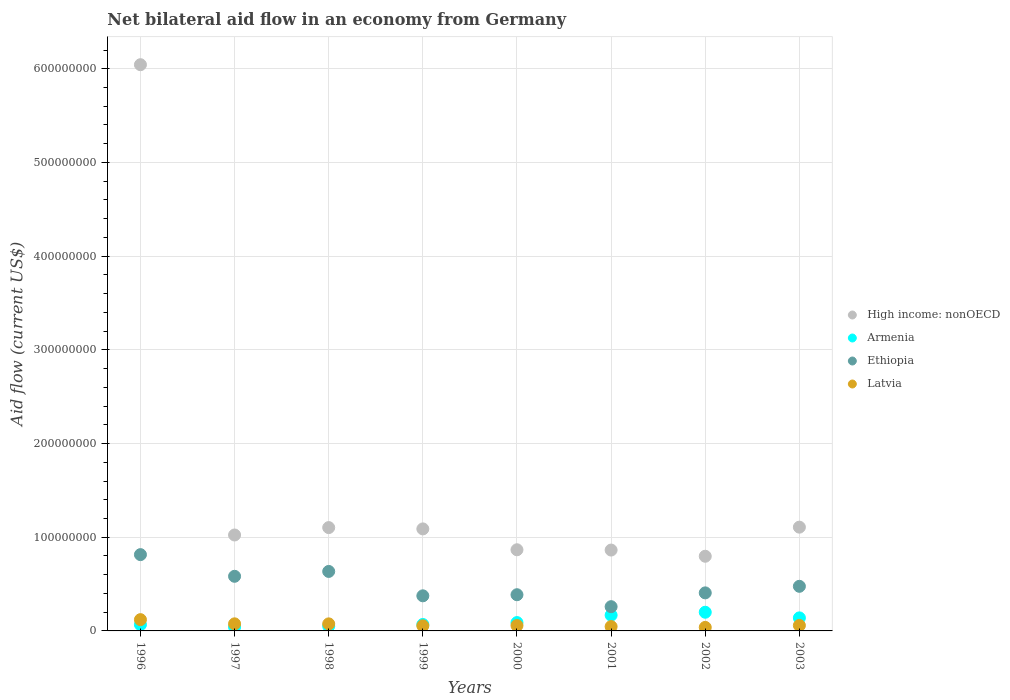How many different coloured dotlines are there?
Keep it short and to the point. 4. What is the net bilateral aid flow in Armenia in 2003?
Give a very brief answer. 1.39e+07. Across all years, what is the maximum net bilateral aid flow in Ethiopia?
Give a very brief answer. 8.14e+07. Across all years, what is the minimum net bilateral aid flow in High income: nonOECD?
Offer a very short reply. 7.97e+07. What is the total net bilateral aid flow in High income: nonOECD in the graph?
Provide a short and direct response. 1.29e+09. What is the difference between the net bilateral aid flow in Latvia in 1996 and that in 2001?
Give a very brief answer. 7.40e+06. What is the difference between the net bilateral aid flow in Armenia in 1998 and the net bilateral aid flow in Latvia in 1997?
Make the answer very short. -2.49e+06. What is the average net bilateral aid flow in Latvia per year?
Offer a very short reply. 6.57e+06. In the year 2000, what is the difference between the net bilateral aid flow in High income: nonOECD and net bilateral aid flow in Latvia?
Make the answer very short. 8.09e+07. What is the ratio of the net bilateral aid flow in High income: nonOECD in 1999 to that in 2001?
Your answer should be very brief. 1.26. Is the net bilateral aid flow in Latvia in 2000 less than that in 2003?
Your response must be concise. Yes. What is the difference between the highest and the second highest net bilateral aid flow in Latvia?
Offer a terse response. 4.47e+06. What is the difference between the highest and the lowest net bilateral aid flow in Ethiopia?
Ensure brevity in your answer.  5.56e+07. In how many years, is the net bilateral aid flow in Armenia greater than the average net bilateral aid flow in Armenia taken over all years?
Give a very brief answer. 3. Is it the case that in every year, the sum of the net bilateral aid flow in Ethiopia and net bilateral aid flow in Latvia  is greater than the net bilateral aid flow in High income: nonOECD?
Give a very brief answer. No. What is the difference between two consecutive major ticks on the Y-axis?
Provide a short and direct response. 1.00e+08. Does the graph contain grids?
Your response must be concise. Yes. Where does the legend appear in the graph?
Provide a succinct answer. Center right. How many legend labels are there?
Your answer should be compact. 4. How are the legend labels stacked?
Provide a short and direct response. Vertical. What is the title of the graph?
Ensure brevity in your answer.  Net bilateral aid flow in an economy from Germany. Does "Portugal" appear as one of the legend labels in the graph?
Make the answer very short. No. What is the label or title of the X-axis?
Offer a very short reply. Years. What is the label or title of the Y-axis?
Ensure brevity in your answer.  Aid flow (current US$). What is the Aid flow (current US$) in High income: nonOECD in 1996?
Your response must be concise. 6.04e+08. What is the Aid flow (current US$) of Armenia in 1996?
Provide a succinct answer. 6.70e+06. What is the Aid flow (current US$) of Ethiopia in 1996?
Give a very brief answer. 8.14e+07. What is the Aid flow (current US$) in Latvia in 1996?
Make the answer very short. 1.20e+07. What is the Aid flow (current US$) of High income: nonOECD in 1997?
Offer a terse response. 1.02e+08. What is the Aid flow (current US$) of Armenia in 1997?
Offer a terse response. 4.11e+06. What is the Aid flow (current US$) of Ethiopia in 1997?
Ensure brevity in your answer.  5.83e+07. What is the Aid flow (current US$) in Latvia in 1997?
Offer a terse response. 7.57e+06. What is the Aid flow (current US$) of High income: nonOECD in 1998?
Give a very brief answer. 1.10e+08. What is the Aid flow (current US$) in Armenia in 1998?
Ensure brevity in your answer.  5.08e+06. What is the Aid flow (current US$) of Ethiopia in 1998?
Ensure brevity in your answer.  6.35e+07. What is the Aid flow (current US$) in Latvia in 1998?
Make the answer very short. 7.53e+06. What is the Aid flow (current US$) of High income: nonOECD in 1999?
Provide a short and direct response. 1.09e+08. What is the Aid flow (current US$) in Armenia in 1999?
Your response must be concise. 6.86e+06. What is the Aid flow (current US$) of Ethiopia in 1999?
Give a very brief answer. 3.75e+07. What is the Aid flow (current US$) in Latvia in 1999?
Your answer should be compact. 5.47e+06. What is the Aid flow (current US$) of High income: nonOECD in 2000?
Offer a very short reply. 8.66e+07. What is the Aid flow (current US$) in Armenia in 2000?
Keep it short and to the point. 8.92e+06. What is the Aid flow (current US$) of Ethiopia in 2000?
Offer a terse response. 3.86e+07. What is the Aid flow (current US$) of Latvia in 2000?
Your answer should be very brief. 5.73e+06. What is the Aid flow (current US$) of High income: nonOECD in 2001?
Offer a very short reply. 8.63e+07. What is the Aid flow (current US$) in Armenia in 2001?
Ensure brevity in your answer.  1.68e+07. What is the Aid flow (current US$) in Ethiopia in 2001?
Keep it short and to the point. 2.59e+07. What is the Aid flow (current US$) of Latvia in 2001?
Your answer should be compact. 4.64e+06. What is the Aid flow (current US$) in High income: nonOECD in 2002?
Your response must be concise. 7.97e+07. What is the Aid flow (current US$) in Armenia in 2002?
Offer a terse response. 1.99e+07. What is the Aid flow (current US$) of Ethiopia in 2002?
Your answer should be very brief. 4.06e+07. What is the Aid flow (current US$) in Latvia in 2002?
Your response must be concise. 3.76e+06. What is the Aid flow (current US$) of High income: nonOECD in 2003?
Give a very brief answer. 1.11e+08. What is the Aid flow (current US$) of Armenia in 2003?
Provide a short and direct response. 1.39e+07. What is the Aid flow (current US$) of Ethiopia in 2003?
Give a very brief answer. 4.76e+07. What is the Aid flow (current US$) in Latvia in 2003?
Offer a terse response. 5.84e+06. Across all years, what is the maximum Aid flow (current US$) in High income: nonOECD?
Offer a very short reply. 6.04e+08. Across all years, what is the maximum Aid flow (current US$) in Armenia?
Provide a succinct answer. 1.99e+07. Across all years, what is the maximum Aid flow (current US$) of Ethiopia?
Your answer should be compact. 8.14e+07. Across all years, what is the maximum Aid flow (current US$) of Latvia?
Provide a short and direct response. 1.20e+07. Across all years, what is the minimum Aid flow (current US$) in High income: nonOECD?
Your response must be concise. 7.97e+07. Across all years, what is the minimum Aid flow (current US$) of Armenia?
Provide a short and direct response. 4.11e+06. Across all years, what is the minimum Aid flow (current US$) in Ethiopia?
Your answer should be compact. 2.59e+07. Across all years, what is the minimum Aid flow (current US$) in Latvia?
Your answer should be very brief. 3.76e+06. What is the total Aid flow (current US$) of High income: nonOECD in the graph?
Ensure brevity in your answer.  1.29e+09. What is the total Aid flow (current US$) of Armenia in the graph?
Make the answer very short. 8.23e+07. What is the total Aid flow (current US$) of Ethiopia in the graph?
Ensure brevity in your answer.  3.93e+08. What is the total Aid flow (current US$) in Latvia in the graph?
Give a very brief answer. 5.26e+07. What is the difference between the Aid flow (current US$) in High income: nonOECD in 1996 and that in 1997?
Provide a short and direct response. 5.02e+08. What is the difference between the Aid flow (current US$) of Armenia in 1996 and that in 1997?
Keep it short and to the point. 2.59e+06. What is the difference between the Aid flow (current US$) in Ethiopia in 1996 and that in 1997?
Your answer should be very brief. 2.31e+07. What is the difference between the Aid flow (current US$) in Latvia in 1996 and that in 1997?
Provide a succinct answer. 4.47e+06. What is the difference between the Aid flow (current US$) of High income: nonOECD in 1996 and that in 1998?
Offer a very short reply. 4.94e+08. What is the difference between the Aid flow (current US$) in Armenia in 1996 and that in 1998?
Ensure brevity in your answer.  1.62e+06. What is the difference between the Aid flow (current US$) in Ethiopia in 1996 and that in 1998?
Give a very brief answer. 1.79e+07. What is the difference between the Aid flow (current US$) in Latvia in 1996 and that in 1998?
Your answer should be very brief. 4.51e+06. What is the difference between the Aid flow (current US$) of High income: nonOECD in 1996 and that in 1999?
Your answer should be very brief. 4.95e+08. What is the difference between the Aid flow (current US$) in Armenia in 1996 and that in 1999?
Offer a terse response. -1.60e+05. What is the difference between the Aid flow (current US$) of Ethiopia in 1996 and that in 1999?
Provide a succinct answer. 4.40e+07. What is the difference between the Aid flow (current US$) of Latvia in 1996 and that in 1999?
Keep it short and to the point. 6.57e+06. What is the difference between the Aid flow (current US$) of High income: nonOECD in 1996 and that in 2000?
Offer a terse response. 5.18e+08. What is the difference between the Aid flow (current US$) of Armenia in 1996 and that in 2000?
Your answer should be compact. -2.22e+06. What is the difference between the Aid flow (current US$) in Ethiopia in 1996 and that in 2000?
Provide a short and direct response. 4.28e+07. What is the difference between the Aid flow (current US$) in Latvia in 1996 and that in 2000?
Provide a succinct answer. 6.31e+06. What is the difference between the Aid flow (current US$) in High income: nonOECD in 1996 and that in 2001?
Provide a succinct answer. 5.18e+08. What is the difference between the Aid flow (current US$) of Armenia in 1996 and that in 2001?
Make the answer very short. -1.01e+07. What is the difference between the Aid flow (current US$) of Ethiopia in 1996 and that in 2001?
Ensure brevity in your answer.  5.56e+07. What is the difference between the Aid flow (current US$) in Latvia in 1996 and that in 2001?
Offer a terse response. 7.40e+06. What is the difference between the Aid flow (current US$) of High income: nonOECD in 1996 and that in 2002?
Ensure brevity in your answer.  5.25e+08. What is the difference between the Aid flow (current US$) of Armenia in 1996 and that in 2002?
Your answer should be compact. -1.32e+07. What is the difference between the Aid flow (current US$) in Ethiopia in 1996 and that in 2002?
Offer a very short reply. 4.08e+07. What is the difference between the Aid flow (current US$) of Latvia in 1996 and that in 2002?
Ensure brevity in your answer.  8.28e+06. What is the difference between the Aid flow (current US$) of High income: nonOECD in 1996 and that in 2003?
Provide a succinct answer. 4.94e+08. What is the difference between the Aid flow (current US$) of Armenia in 1996 and that in 2003?
Your answer should be compact. -7.22e+06. What is the difference between the Aid flow (current US$) in Ethiopia in 1996 and that in 2003?
Provide a succinct answer. 3.38e+07. What is the difference between the Aid flow (current US$) of Latvia in 1996 and that in 2003?
Ensure brevity in your answer.  6.20e+06. What is the difference between the Aid flow (current US$) of High income: nonOECD in 1997 and that in 1998?
Your response must be concise. -7.90e+06. What is the difference between the Aid flow (current US$) of Armenia in 1997 and that in 1998?
Your response must be concise. -9.70e+05. What is the difference between the Aid flow (current US$) in Ethiopia in 1997 and that in 1998?
Your answer should be very brief. -5.19e+06. What is the difference between the Aid flow (current US$) in Latvia in 1997 and that in 1998?
Ensure brevity in your answer.  4.00e+04. What is the difference between the Aid flow (current US$) in High income: nonOECD in 1997 and that in 1999?
Your response must be concise. -6.50e+06. What is the difference between the Aid flow (current US$) in Armenia in 1997 and that in 1999?
Keep it short and to the point. -2.75e+06. What is the difference between the Aid flow (current US$) in Ethiopia in 1997 and that in 1999?
Your answer should be compact. 2.08e+07. What is the difference between the Aid flow (current US$) in Latvia in 1997 and that in 1999?
Ensure brevity in your answer.  2.10e+06. What is the difference between the Aid flow (current US$) of High income: nonOECD in 1997 and that in 2000?
Your answer should be compact. 1.58e+07. What is the difference between the Aid flow (current US$) in Armenia in 1997 and that in 2000?
Give a very brief answer. -4.81e+06. What is the difference between the Aid flow (current US$) in Ethiopia in 1997 and that in 2000?
Your answer should be compact. 1.97e+07. What is the difference between the Aid flow (current US$) of Latvia in 1997 and that in 2000?
Provide a succinct answer. 1.84e+06. What is the difference between the Aid flow (current US$) of High income: nonOECD in 1997 and that in 2001?
Offer a very short reply. 1.61e+07. What is the difference between the Aid flow (current US$) in Armenia in 1997 and that in 2001?
Make the answer very short. -1.27e+07. What is the difference between the Aid flow (current US$) in Ethiopia in 1997 and that in 2001?
Your answer should be very brief. 3.24e+07. What is the difference between the Aid flow (current US$) in Latvia in 1997 and that in 2001?
Your answer should be very brief. 2.93e+06. What is the difference between the Aid flow (current US$) in High income: nonOECD in 1997 and that in 2002?
Give a very brief answer. 2.27e+07. What is the difference between the Aid flow (current US$) in Armenia in 1997 and that in 2002?
Your response must be concise. -1.58e+07. What is the difference between the Aid flow (current US$) in Ethiopia in 1997 and that in 2002?
Provide a short and direct response. 1.77e+07. What is the difference between the Aid flow (current US$) of Latvia in 1997 and that in 2002?
Your response must be concise. 3.81e+06. What is the difference between the Aid flow (current US$) of High income: nonOECD in 1997 and that in 2003?
Give a very brief answer. -8.36e+06. What is the difference between the Aid flow (current US$) of Armenia in 1997 and that in 2003?
Provide a short and direct response. -9.81e+06. What is the difference between the Aid flow (current US$) of Ethiopia in 1997 and that in 2003?
Provide a succinct answer. 1.07e+07. What is the difference between the Aid flow (current US$) in Latvia in 1997 and that in 2003?
Make the answer very short. 1.73e+06. What is the difference between the Aid flow (current US$) of High income: nonOECD in 1998 and that in 1999?
Ensure brevity in your answer.  1.40e+06. What is the difference between the Aid flow (current US$) of Armenia in 1998 and that in 1999?
Offer a very short reply. -1.78e+06. What is the difference between the Aid flow (current US$) of Ethiopia in 1998 and that in 1999?
Offer a terse response. 2.60e+07. What is the difference between the Aid flow (current US$) of Latvia in 1998 and that in 1999?
Ensure brevity in your answer.  2.06e+06. What is the difference between the Aid flow (current US$) of High income: nonOECD in 1998 and that in 2000?
Keep it short and to the point. 2.37e+07. What is the difference between the Aid flow (current US$) in Armenia in 1998 and that in 2000?
Your response must be concise. -3.84e+06. What is the difference between the Aid flow (current US$) of Ethiopia in 1998 and that in 2000?
Your answer should be very brief. 2.49e+07. What is the difference between the Aid flow (current US$) in Latvia in 1998 and that in 2000?
Your response must be concise. 1.80e+06. What is the difference between the Aid flow (current US$) in High income: nonOECD in 1998 and that in 2001?
Make the answer very short. 2.40e+07. What is the difference between the Aid flow (current US$) in Armenia in 1998 and that in 2001?
Offer a terse response. -1.17e+07. What is the difference between the Aid flow (current US$) of Ethiopia in 1998 and that in 2001?
Offer a terse response. 3.76e+07. What is the difference between the Aid flow (current US$) in Latvia in 1998 and that in 2001?
Offer a very short reply. 2.89e+06. What is the difference between the Aid flow (current US$) in High income: nonOECD in 1998 and that in 2002?
Keep it short and to the point. 3.06e+07. What is the difference between the Aid flow (current US$) in Armenia in 1998 and that in 2002?
Your response must be concise. -1.49e+07. What is the difference between the Aid flow (current US$) in Ethiopia in 1998 and that in 2002?
Keep it short and to the point. 2.29e+07. What is the difference between the Aid flow (current US$) in Latvia in 1998 and that in 2002?
Keep it short and to the point. 3.77e+06. What is the difference between the Aid flow (current US$) in High income: nonOECD in 1998 and that in 2003?
Keep it short and to the point. -4.60e+05. What is the difference between the Aid flow (current US$) in Armenia in 1998 and that in 2003?
Your response must be concise. -8.84e+06. What is the difference between the Aid flow (current US$) of Ethiopia in 1998 and that in 2003?
Keep it short and to the point. 1.59e+07. What is the difference between the Aid flow (current US$) in Latvia in 1998 and that in 2003?
Keep it short and to the point. 1.69e+06. What is the difference between the Aid flow (current US$) of High income: nonOECD in 1999 and that in 2000?
Your answer should be very brief. 2.23e+07. What is the difference between the Aid flow (current US$) in Armenia in 1999 and that in 2000?
Offer a very short reply. -2.06e+06. What is the difference between the Aid flow (current US$) in Ethiopia in 1999 and that in 2000?
Your answer should be compact. -1.17e+06. What is the difference between the Aid flow (current US$) in High income: nonOECD in 1999 and that in 2001?
Your answer should be compact. 2.26e+07. What is the difference between the Aid flow (current US$) in Armenia in 1999 and that in 2001?
Your answer should be very brief. -9.94e+06. What is the difference between the Aid flow (current US$) of Ethiopia in 1999 and that in 2001?
Provide a short and direct response. 1.16e+07. What is the difference between the Aid flow (current US$) in Latvia in 1999 and that in 2001?
Give a very brief answer. 8.30e+05. What is the difference between the Aid flow (current US$) in High income: nonOECD in 1999 and that in 2002?
Your answer should be compact. 2.92e+07. What is the difference between the Aid flow (current US$) of Armenia in 1999 and that in 2002?
Your response must be concise. -1.31e+07. What is the difference between the Aid flow (current US$) of Ethiopia in 1999 and that in 2002?
Provide a succinct answer. -3.15e+06. What is the difference between the Aid flow (current US$) in Latvia in 1999 and that in 2002?
Ensure brevity in your answer.  1.71e+06. What is the difference between the Aid flow (current US$) in High income: nonOECD in 1999 and that in 2003?
Ensure brevity in your answer.  -1.86e+06. What is the difference between the Aid flow (current US$) of Armenia in 1999 and that in 2003?
Offer a very short reply. -7.06e+06. What is the difference between the Aid flow (current US$) of Ethiopia in 1999 and that in 2003?
Offer a very short reply. -1.02e+07. What is the difference between the Aid flow (current US$) in Latvia in 1999 and that in 2003?
Make the answer very short. -3.70e+05. What is the difference between the Aid flow (current US$) in Armenia in 2000 and that in 2001?
Make the answer very short. -7.88e+06. What is the difference between the Aid flow (current US$) in Ethiopia in 2000 and that in 2001?
Ensure brevity in your answer.  1.28e+07. What is the difference between the Aid flow (current US$) of Latvia in 2000 and that in 2001?
Your answer should be very brief. 1.09e+06. What is the difference between the Aid flow (current US$) of High income: nonOECD in 2000 and that in 2002?
Keep it short and to the point. 6.92e+06. What is the difference between the Aid flow (current US$) in Armenia in 2000 and that in 2002?
Offer a very short reply. -1.10e+07. What is the difference between the Aid flow (current US$) of Ethiopia in 2000 and that in 2002?
Give a very brief answer. -1.98e+06. What is the difference between the Aid flow (current US$) in Latvia in 2000 and that in 2002?
Provide a succinct answer. 1.97e+06. What is the difference between the Aid flow (current US$) of High income: nonOECD in 2000 and that in 2003?
Provide a short and direct response. -2.41e+07. What is the difference between the Aid flow (current US$) of Armenia in 2000 and that in 2003?
Offer a terse response. -5.00e+06. What is the difference between the Aid flow (current US$) of Ethiopia in 2000 and that in 2003?
Offer a terse response. -8.98e+06. What is the difference between the Aid flow (current US$) in Latvia in 2000 and that in 2003?
Give a very brief answer. -1.10e+05. What is the difference between the Aid flow (current US$) of High income: nonOECD in 2001 and that in 2002?
Your answer should be compact. 6.62e+06. What is the difference between the Aid flow (current US$) in Armenia in 2001 and that in 2002?
Make the answer very short. -3.14e+06. What is the difference between the Aid flow (current US$) of Ethiopia in 2001 and that in 2002?
Your answer should be very brief. -1.47e+07. What is the difference between the Aid flow (current US$) in Latvia in 2001 and that in 2002?
Provide a short and direct response. 8.80e+05. What is the difference between the Aid flow (current US$) of High income: nonOECD in 2001 and that in 2003?
Provide a short and direct response. -2.44e+07. What is the difference between the Aid flow (current US$) of Armenia in 2001 and that in 2003?
Keep it short and to the point. 2.88e+06. What is the difference between the Aid flow (current US$) in Ethiopia in 2001 and that in 2003?
Ensure brevity in your answer.  -2.17e+07. What is the difference between the Aid flow (current US$) in Latvia in 2001 and that in 2003?
Offer a terse response. -1.20e+06. What is the difference between the Aid flow (current US$) of High income: nonOECD in 2002 and that in 2003?
Ensure brevity in your answer.  -3.11e+07. What is the difference between the Aid flow (current US$) in Armenia in 2002 and that in 2003?
Offer a very short reply. 6.02e+06. What is the difference between the Aid flow (current US$) in Ethiopia in 2002 and that in 2003?
Provide a short and direct response. -7.00e+06. What is the difference between the Aid flow (current US$) in Latvia in 2002 and that in 2003?
Provide a succinct answer. -2.08e+06. What is the difference between the Aid flow (current US$) in High income: nonOECD in 1996 and the Aid flow (current US$) in Armenia in 1997?
Your answer should be compact. 6.00e+08. What is the difference between the Aid flow (current US$) in High income: nonOECD in 1996 and the Aid flow (current US$) in Ethiopia in 1997?
Give a very brief answer. 5.46e+08. What is the difference between the Aid flow (current US$) in High income: nonOECD in 1996 and the Aid flow (current US$) in Latvia in 1997?
Keep it short and to the point. 5.97e+08. What is the difference between the Aid flow (current US$) of Armenia in 1996 and the Aid flow (current US$) of Ethiopia in 1997?
Offer a terse response. -5.16e+07. What is the difference between the Aid flow (current US$) in Armenia in 1996 and the Aid flow (current US$) in Latvia in 1997?
Your answer should be very brief. -8.70e+05. What is the difference between the Aid flow (current US$) of Ethiopia in 1996 and the Aid flow (current US$) of Latvia in 1997?
Ensure brevity in your answer.  7.39e+07. What is the difference between the Aid flow (current US$) in High income: nonOECD in 1996 and the Aid flow (current US$) in Armenia in 1998?
Ensure brevity in your answer.  5.99e+08. What is the difference between the Aid flow (current US$) of High income: nonOECD in 1996 and the Aid flow (current US$) of Ethiopia in 1998?
Ensure brevity in your answer.  5.41e+08. What is the difference between the Aid flow (current US$) in High income: nonOECD in 1996 and the Aid flow (current US$) in Latvia in 1998?
Provide a short and direct response. 5.97e+08. What is the difference between the Aid flow (current US$) in Armenia in 1996 and the Aid flow (current US$) in Ethiopia in 1998?
Provide a short and direct response. -5.68e+07. What is the difference between the Aid flow (current US$) of Armenia in 1996 and the Aid flow (current US$) of Latvia in 1998?
Your answer should be very brief. -8.30e+05. What is the difference between the Aid flow (current US$) of Ethiopia in 1996 and the Aid flow (current US$) of Latvia in 1998?
Give a very brief answer. 7.39e+07. What is the difference between the Aid flow (current US$) in High income: nonOECD in 1996 and the Aid flow (current US$) in Armenia in 1999?
Your answer should be compact. 5.97e+08. What is the difference between the Aid flow (current US$) in High income: nonOECD in 1996 and the Aid flow (current US$) in Ethiopia in 1999?
Give a very brief answer. 5.67e+08. What is the difference between the Aid flow (current US$) of High income: nonOECD in 1996 and the Aid flow (current US$) of Latvia in 1999?
Your answer should be very brief. 5.99e+08. What is the difference between the Aid flow (current US$) of Armenia in 1996 and the Aid flow (current US$) of Ethiopia in 1999?
Ensure brevity in your answer.  -3.08e+07. What is the difference between the Aid flow (current US$) of Armenia in 1996 and the Aid flow (current US$) of Latvia in 1999?
Offer a very short reply. 1.23e+06. What is the difference between the Aid flow (current US$) in Ethiopia in 1996 and the Aid flow (current US$) in Latvia in 1999?
Provide a short and direct response. 7.60e+07. What is the difference between the Aid flow (current US$) in High income: nonOECD in 1996 and the Aid flow (current US$) in Armenia in 2000?
Provide a succinct answer. 5.95e+08. What is the difference between the Aid flow (current US$) in High income: nonOECD in 1996 and the Aid flow (current US$) in Ethiopia in 2000?
Ensure brevity in your answer.  5.66e+08. What is the difference between the Aid flow (current US$) of High income: nonOECD in 1996 and the Aid flow (current US$) of Latvia in 2000?
Offer a very short reply. 5.99e+08. What is the difference between the Aid flow (current US$) of Armenia in 1996 and the Aid flow (current US$) of Ethiopia in 2000?
Make the answer very short. -3.19e+07. What is the difference between the Aid flow (current US$) of Armenia in 1996 and the Aid flow (current US$) of Latvia in 2000?
Offer a terse response. 9.70e+05. What is the difference between the Aid flow (current US$) of Ethiopia in 1996 and the Aid flow (current US$) of Latvia in 2000?
Offer a very short reply. 7.57e+07. What is the difference between the Aid flow (current US$) of High income: nonOECD in 1996 and the Aid flow (current US$) of Armenia in 2001?
Provide a succinct answer. 5.88e+08. What is the difference between the Aid flow (current US$) of High income: nonOECD in 1996 and the Aid flow (current US$) of Ethiopia in 2001?
Make the answer very short. 5.78e+08. What is the difference between the Aid flow (current US$) in High income: nonOECD in 1996 and the Aid flow (current US$) in Latvia in 2001?
Give a very brief answer. 6.00e+08. What is the difference between the Aid flow (current US$) of Armenia in 1996 and the Aid flow (current US$) of Ethiopia in 2001?
Give a very brief answer. -1.92e+07. What is the difference between the Aid flow (current US$) in Armenia in 1996 and the Aid flow (current US$) in Latvia in 2001?
Provide a succinct answer. 2.06e+06. What is the difference between the Aid flow (current US$) in Ethiopia in 1996 and the Aid flow (current US$) in Latvia in 2001?
Give a very brief answer. 7.68e+07. What is the difference between the Aid flow (current US$) in High income: nonOECD in 1996 and the Aid flow (current US$) in Armenia in 2002?
Provide a succinct answer. 5.84e+08. What is the difference between the Aid flow (current US$) of High income: nonOECD in 1996 and the Aid flow (current US$) of Ethiopia in 2002?
Your answer should be compact. 5.64e+08. What is the difference between the Aid flow (current US$) in High income: nonOECD in 1996 and the Aid flow (current US$) in Latvia in 2002?
Provide a succinct answer. 6.01e+08. What is the difference between the Aid flow (current US$) of Armenia in 1996 and the Aid flow (current US$) of Ethiopia in 2002?
Your answer should be compact. -3.39e+07. What is the difference between the Aid flow (current US$) in Armenia in 1996 and the Aid flow (current US$) in Latvia in 2002?
Provide a short and direct response. 2.94e+06. What is the difference between the Aid flow (current US$) of Ethiopia in 1996 and the Aid flow (current US$) of Latvia in 2002?
Your answer should be very brief. 7.77e+07. What is the difference between the Aid flow (current US$) of High income: nonOECD in 1996 and the Aid flow (current US$) of Armenia in 2003?
Ensure brevity in your answer.  5.90e+08. What is the difference between the Aid flow (current US$) in High income: nonOECD in 1996 and the Aid flow (current US$) in Ethiopia in 2003?
Ensure brevity in your answer.  5.57e+08. What is the difference between the Aid flow (current US$) in High income: nonOECD in 1996 and the Aid flow (current US$) in Latvia in 2003?
Ensure brevity in your answer.  5.98e+08. What is the difference between the Aid flow (current US$) in Armenia in 1996 and the Aid flow (current US$) in Ethiopia in 2003?
Offer a terse response. -4.09e+07. What is the difference between the Aid flow (current US$) of Armenia in 1996 and the Aid flow (current US$) of Latvia in 2003?
Ensure brevity in your answer.  8.60e+05. What is the difference between the Aid flow (current US$) in Ethiopia in 1996 and the Aid flow (current US$) in Latvia in 2003?
Offer a terse response. 7.56e+07. What is the difference between the Aid flow (current US$) in High income: nonOECD in 1997 and the Aid flow (current US$) in Armenia in 1998?
Give a very brief answer. 9.73e+07. What is the difference between the Aid flow (current US$) of High income: nonOECD in 1997 and the Aid flow (current US$) of Ethiopia in 1998?
Provide a succinct answer. 3.89e+07. What is the difference between the Aid flow (current US$) in High income: nonOECD in 1997 and the Aid flow (current US$) in Latvia in 1998?
Keep it short and to the point. 9.49e+07. What is the difference between the Aid flow (current US$) in Armenia in 1997 and the Aid flow (current US$) in Ethiopia in 1998?
Offer a terse response. -5.94e+07. What is the difference between the Aid flow (current US$) in Armenia in 1997 and the Aid flow (current US$) in Latvia in 1998?
Ensure brevity in your answer.  -3.42e+06. What is the difference between the Aid flow (current US$) of Ethiopia in 1997 and the Aid flow (current US$) of Latvia in 1998?
Provide a short and direct response. 5.08e+07. What is the difference between the Aid flow (current US$) in High income: nonOECD in 1997 and the Aid flow (current US$) in Armenia in 1999?
Your answer should be very brief. 9.55e+07. What is the difference between the Aid flow (current US$) in High income: nonOECD in 1997 and the Aid flow (current US$) in Ethiopia in 1999?
Offer a terse response. 6.49e+07. What is the difference between the Aid flow (current US$) in High income: nonOECD in 1997 and the Aid flow (current US$) in Latvia in 1999?
Keep it short and to the point. 9.69e+07. What is the difference between the Aid flow (current US$) of Armenia in 1997 and the Aid flow (current US$) of Ethiopia in 1999?
Ensure brevity in your answer.  -3.34e+07. What is the difference between the Aid flow (current US$) of Armenia in 1997 and the Aid flow (current US$) of Latvia in 1999?
Your response must be concise. -1.36e+06. What is the difference between the Aid flow (current US$) in Ethiopia in 1997 and the Aid flow (current US$) in Latvia in 1999?
Provide a short and direct response. 5.28e+07. What is the difference between the Aid flow (current US$) in High income: nonOECD in 1997 and the Aid flow (current US$) in Armenia in 2000?
Offer a very short reply. 9.35e+07. What is the difference between the Aid flow (current US$) of High income: nonOECD in 1997 and the Aid flow (current US$) of Ethiopia in 2000?
Provide a short and direct response. 6.38e+07. What is the difference between the Aid flow (current US$) of High income: nonOECD in 1997 and the Aid flow (current US$) of Latvia in 2000?
Ensure brevity in your answer.  9.67e+07. What is the difference between the Aid flow (current US$) of Armenia in 1997 and the Aid flow (current US$) of Ethiopia in 2000?
Your answer should be compact. -3.45e+07. What is the difference between the Aid flow (current US$) of Armenia in 1997 and the Aid flow (current US$) of Latvia in 2000?
Offer a very short reply. -1.62e+06. What is the difference between the Aid flow (current US$) of Ethiopia in 1997 and the Aid flow (current US$) of Latvia in 2000?
Your answer should be compact. 5.26e+07. What is the difference between the Aid flow (current US$) of High income: nonOECD in 1997 and the Aid flow (current US$) of Armenia in 2001?
Your answer should be very brief. 8.56e+07. What is the difference between the Aid flow (current US$) of High income: nonOECD in 1997 and the Aid flow (current US$) of Ethiopia in 2001?
Your response must be concise. 7.65e+07. What is the difference between the Aid flow (current US$) in High income: nonOECD in 1997 and the Aid flow (current US$) in Latvia in 2001?
Keep it short and to the point. 9.78e+07. What is the difference between the Aid flow (current US$) in Armenia in 1997 and the Aid flow (current US$) in Ethiopia in 2001?
Your response must be concise. -2.18e+07. What is the difference between the Aid flow (current US$) in Armenia in 1997 and the Aid flow (current US$) in Latvia in 2001?
Provide a short and direct response. -5.30e+05. What is the difference between the Aid flow (current US$) of Ethiopia in 1997 and the Aid flow (current US$) of Latvia in 2001?
Your answer should be very brief. 5.37e+07. What is the difference between the Aid flow (current US$) of High income: nonOECD in 1997 and the Aid flow (current US$) of Armenia in 2002?
Your response must be concise. 8.24e+07. What is the difference between the Aid flow (current US$) in High income: nonOECD in 1997 and the Aid flow (current US$) in Ethiopia in 2002?
Provide a succinct answer. 6.18e+07. What is the difference between the Aid flow (current US$) in High income: nonOECD in 1997 and the Aid flow (current US$) in Latvia in 2002?
Offer a terse response. 9.86e+07. What is the difference between the Aid flow (current US$) of Armenia in 1997 and the Aid flow (current US$) of Ethiopia in 2002?
Ensure brevity in your answer.  -3.65e+07. What is the difference between the Aid flow (current US$) of Ethiopia in 1997 and the Aid flow (current US$) of Latvia in 2002?
Ensure brevity in your answer.  5.45e+07. What is the difference between the Aid flow (current US$) of High income: nonOECD in 1997 and the Aid flow (current US$) of Armenia in 2003?
Give a very brief answer. 8.85e+07. What is the difference between the Aid flow (current US$) in High income: nonOECD in 1997 and the Aid flow (current US$) in Ethiopia in 2003?
Offer a terse response. 5.48e+07. What is the difference between the Aid flow (current US$) in High income: nonOECD in 1997 and the Aid flow (current US$) in Latvia in 2003?
Ensure brevity in your answer.  9.66e+07. What is the difference between the Aid flow (current US$) in Armenia in 1997 and the Aid flow (current US$) in Ethiopia in 2003?
Provide a short and direct response. -4.35e+07. What is the difference between the Aid flow (current US$) in Armenia in 1997 and the Aid flow (current US$) in Latvia in 2003?
Offer a very short reply. -1.73e+06. What is the difference between the Aid flow (current US$) of Ethiopia in 1997 and the Aid flow (current US$) of Latvia in 2003?
Your answer should be very brief. 5.25e+07. What is the difference between the Aid flow (current US$) in High income: nonOECD in 1998 and the Aid flow (current US$) in Armenia in 1999?
Keep it short and to the point. 1.03e+08. What is the difference between the Aid flow (current US$) in High income: nonOECD in 1998 and the Aid flow (current US$) in Ethiopia in 1999?
Ensure brevity in your answer.  7.28e+07. What is the difference between the Aid flow (current US$) in High income: nonOECD in 1998 and the Aid flow (current US$) in Latvia in 1999?
Your answer should be very brief. 1.05e+08. What is the difference between the Aid flow (current US$) of Armenia in 1998 and the Aid flow (current US$) of Ethiopia in 1999?
Keep it short and to the point. -3.24e+07. What is the difference between the Aid flow (current US$) of Armenia in 1998 and the Aid flow (current US$) of Latvia in 1999?
Offer a terse response. -3.90e+05. What is the difference between the Aid flow (current US$) in Ethiopia in 1998 and the Aid flow (current US$) in Latvia in 1999?
Your answer should be very brief. 5.80e+07. What is the difference between the Aid flow (current US$) in High income: nonOECD in 1998 and the Aid flow (current US$) in Armenia in 2000?
Your answer should be compact. 1.01e+08. What is the difference between the Aid flow (current US$) of High income: nonOECD in 1998 and the Aid flow (current US$) of Ethiopia in 2000?
Ensure brevity in your answer.  7.17e+07. What is the difference between the Aid flow (current US$) in High income: nonOECD in 1998 and the Aid flow (current US$) in Latvia in 2000?
Offer a terse response. 1.05e+08. What is the difference between the Aid flow (current US$) in Armenia in 1998 and the Aid flow (current US$) in Ethiopia in 2000?
Your answer should be compact. -3.36e+07. What is the difference between the Aid flow (current US$) in Armenia in 1998 and the Aid flow (current US$) in Latvia in 2000?
Keep it short and to the point. -6.50e+05. What is the difference between the Aid flow (current US$) of Ethiopia in 1998 and the Aid flow (current US$) of Latvia in 2000?
Your answer should be compact. 5.78e+07. What is the difference between the Aid flow (current US$) in High income: nonOECD in 1998 and the Aid flow (current US$) in Armenia in 2001?
Provide a succinct answer. 9.35e+07. What is the difference between the Aid flow (current US$) in High income: nonOECD in 1998 and the Aid flow (current US$) in Ethiopia in 2001?
Provide a succinct answer. 8.44e+07. What is the difference between the Aid flow (current US$) in High income: nonOECD in 1998 and the Aid flow (current US$) in Latvia in 2001?
Ensure brevity in your answer.  1.06e+08. What is the difference between the Aid flow (current US$) of Armenia in 1998 and the Aid flow (current US$) of Ethiopia in 2001?
Your response must be concise. -2.08e+07. What is the difference between the Aid flow (current US$) in Armenia in 1998 and the Aid flow (current US$) in Latvia in 2001?
Offer a very short reply. 4.40e+05. What is the difference between the Aid flow (current US$) in Ethiopia in 1998 and the Aid flow (current US$) in Latvia in 2001?
Your answer should be compact. 5.88e+07. What is the difference between the Aid flow (current US$) in High income: nonOECD in 1998 and the Aid flow (current US$) in Armenia in 2002?
Your response must be concise. 9.04e+07. What is the difference between the Aid flow (current US$) in High income: nonOECD in 1998 and the Aid flow (current US$) in Ethiopia in 2002?
Give a very brief answer. 6.97e+07. What is the difference between the Aid flow (current US$) of High income: nonOECD in 1998 and the Aid flow (current US$) of Latvia in 2002?
Offer a terse response. 1.07e+08. What is the difference between the Aid flow (current US$) in Armenia in 1998 and the Aid flow (current US$) in Ethiopia in 2002?
Your response must be concise. -3.55e+07. What is the difference between the Aid flow (current US$) in Armenia in 1998 and the Aid flow (current US$) in Latvia in 2002?
Offer a very short reply. 1.32e+06. What is the difference between the Aid flow (current US$) in Ethiopia in 1998 and the Aid flow (current US$) in Latvia in 2002?
Your answer should be very brief. 5.97e+07. What is the difference between the Aid flow (current US$) of High income: nonOECD in 1998 and the Aid flow (current US$) of Armenia in 2003?
Make the answer very short. 9.64e+07. What is the difference between the Aid flow (current US$) of High income: nonOECD in 1998 and the Aid flow (current US$) of Ethiopia in 2003?
Ensure brevity in your answer.  6.27e+07. What is the difference between the Aid flow (current US$) in High income: nonOECD in 1998 and the Aid flow (current US$) in Latvia in 2003?
Make the answer very short. 1.04e+08. What is the difference between the Aid flow (current US$) in Armenia in 1998 and the Aid flow (current US$) in Ethiopia in 2003?
Your answer should be very brief. -4.25e+07. What is the difference between the Aid flow (current US$) of Armenia in 1998 and the Aid flow (current US$) of Latvia in 2003?
Make the answer very short. -7.60e+05. What is the difference between the Aid flow (current US$) in Ethiopia in 1998 and the Aid flow (current US$) in Latvia in 2003?
Give a very brief answer. 5.76e+07. What is the difference between the Aid flow (current US$) in High income: nonOECD in 1999 and the Aid flow (current US$) in Armenia in 2000?
Your response must be concise. 1.00e+08. What is the difference between the Aid flow (current US$) in High income: nonOECD in 1999 and the Aid flow (current US$) in Ethiopia in 2000?
Provide a short and direct response. 7.03e+07. What is the difference between the Aid flow (current US$) in High income: nonOECD in 1999 and the Aid flow (current US$) in Latvia in 2000?
Provide a short and direct response. 1.03e+08. What is the difference between the Aid flow (current US$) in Armenia in 1999 and the Aid flow (current US$) in Ethiopia in 2000?
Make the answer very short. -3.18e+07. What is the difference between the Aid flow (current US$) in Armenia in 1999 and the Aid flow (current US$) in Latvia in 2000?
Keep it short and to the point. 1.13e+06. What is the difference between the Aid flow (current US$) in Ethiopia in 1999 and the Aid flow (current US$) in Latvia in 2000?
Ensure brevity in your answer.  3.17e+07. What is the difference between the Aid flow (current US$) in High income: nonOECD in 1999 and the Aid flow (current US$) in Armenia in 2001?
Your answer should be very brief. 9.21e+07. What is the difference between the Aid flow (current US$) in High income: nonOECD in 1999 and the Aid flow (current US$) in Ethiopia in 2001?
Provide a short and direct response. 8.30e+07. What is the difference between the Aid flow (current US$) of High income: nonOECD in 1999 and the Aid flow (current US$) of Latvia in 2001?
Give a very brief answer. 1.04e+08. What is the difference between the Aid flow (current US$) in Armenia in 1999 and the Aid flow (current US$) in Ethiopia in 2001?
Provide a short and direct response. -1.90e+07. What is the difference between the Aid flow (current US$) of Armenia in 1999 and the Aid flow (current US$) of Latvia in 2001?
Offer a very short reply. 2.22e+06. What is the difference between the Aid flow (current US$) of Ethiopia in 1999 and the Aid flow (current US$) of Latvia in 2001?
Provide a succinct answer. 3.28e+07. What is the difference between the Aid flow (current US$) in High income: nonOECD in 1999 and the Aid flow (current US$) in Armenia in 2002?
Your answer should be very brief. 8.90e+07. What is the difference between the Aid flow (current US$) of High income: nonOECD in 1999 and the Aid flow (current US$) of Ethiopia in 2002?
Your answer should be compact. 6.83e+07. What is the difference between the Aid flow (current US$) of High income: nonOECD in 1999 and the Aid flow (current US$) of Latvia in 2002?
Ensure brevity in your answer.  1.05e+08. What is the difference between the Aid flow (current US$) of Armenia in 1999 and the Aid flow (current US$) of Ethiopia in 2002?
Make the answer very short. -3.38e+07. What is the difference between the Aid flow (current US$) of Armenia in 1999 and the Aid flow (current US$) of Latvia in 2002?
Give a very brief answer. 3.10e+06. What is the difference between the Aid flow (current US$) of Ethiopia in 1999 and the Aid flow (current US$) of Latvia in 2002?
Your response must be concise. 3.37e+07. What is the difference between the Aid flow (current US$) in High income: nonOECD in 1999 and the Aid flow (current US$) in Armenia in 2003?
Make the answer very short. 9.50e+07. What is the difference between the Aid flow (current US$) in High income: nonOECD in 1999 and the Aid flow (current US$) in Ethiopia in 2003?
Offer a terse response. 6.13e+07. What is the difference between the Aid flow (current US$) of High income: nonOECD in 1999 and the Aid flow (current US$) of Latvia in 2003?
Give a very brief answer. 1.03e+08. What is the difference between the Aid flow (current US$) of Armenia in 1999 and the Aid flow (current US$) of Ethiopia in 2003?
Provide a succinct answer. -4.08e+07. What is the difference between the Aid flow (current US$) of Armenia in 1999 and the Aid flow (current US$) of Latvia in 2003?
Offer a terse response. 1.02e+06. What is the difference between the Aid flow (current US$) in Ethiopia in 1999 and the Aid flow (current US$) in Latvia in 2003?
Keep it short and to the point. 3.16e+07. What is the difference between the Aid flow (current US$) of High income: nonOECD in 2000 and the Aid flow (current US$) of Armenia in 2001?
Your response must be concise. 6.98e+07. What is the difference between the Aid flow (current US$) of High income: nonOECD in 2000 and the Aid flow (current US$) of Ethiopia in 2001?
Provide a short and direct response. 6.07e+07. What is the difference between the Aid flow (current US$) in High income: nonOECD in 2000 and the Aid flow (current US$) in Latvia in 2001?
Keep it short and to the point. 8.20e+07. What is the difference between the Aid flow (current US$) in Armenia in 2000 and the Aid flow (current US$) in Ethiopia in 2001?
Provide a short and direct response. -1.70e+07. What is the difference between the Aid flow (current US$) in Armenia in 2000 and the Aid flow (current US$) in Latvia in 2001?
Give a very brief answer. 4.28e+06. What is the difference between the Aid flow (current US$) in Ethiopia in 2000 and the Aid flow (current US$) in Latvia in 2001?
Keep it short and to the point. 3.40e+07. What is the difference between the Aid flow (current US$) in High income: nonOECD in 2000 and the Aid flow (current US$) in Armenia in 2002?
Offer a terse response. 6.67e+07. What is the difference between the Aid flow (current US$) in High income: nonOECD in 2000 and the Aid flow (current US$) in Ethiopia in 2002?
Provide a short and direct response. 4.60e+07. What is the difference between the Aid flow (current US$) of High income: nonOECD in 2000 and the Aid flow (current US$) of Latvia in 2002?
Offer a terse response. 8.28e+07. What is the difference between the Aid flow (current US$) in Armenia in 2000 and the Aid flow (current US$) in Ethiopia in 2002?
Provide a short and direct response. -3.17e+07. What is the difference between the Aid flow (current US$) in Armenia in 2000 and the Aid flow (current US$) in Latvia in 2002?
Provide a short and direct response. 5.16e+06. What is the difference between the Aid flow (current US$) in Ethiopia in 2000 and the Aid flow (current US$) in Latvia in 2002?
Make the answer very short. 3.49e+07. What is the difference between the Aid flow (current US$) in High income: nonOECD in 2000 and the Aid flow (current US$) in Armenia in 2003?
Your answer should be compact. 7.27e+07. What is the difference between the Aid flow (current US$) in High income: nonOECD in 2000 and the Aid flow (current US$) in Ethiopia in 2003?
Provide a short and direct response. 3.90e+07. What is the difference between the Aid flow (current US$) of High income: nonOECD in 2000 and the Aid flow (current US$) of Latvia in 2003?
Give a very brief answer. 8.08e+07. What is the difference between the Aid flow (current US$) in Armenia in 2000 and the Aid flow (current US$) in Ethiopia in 2003?
Provide a short and direct response. -3.87e+07. What is the difference between the Aid flow (current US$) of Armenia in 2000 and the Aid flow (current US$) of Latvia in 2003?
Make the answer very short. 3.08e+06. What is the difference between the Aid flow (current US$) in Ethiopia in 2000 and the Aid flow (current US$) in Latvia in 2003?
Provide a short and direct response. 3.28e+07. What is the difference between the Aid flow (current US$) in High income: nonOECD in 2001 and the Aid flow (current US$) in Armenia in 2002?
Give a very brief answer. 6.64e+07. What is the difference between the Aid flow (current US$) of High income: nonOECD in 2001 and the Aid flow (current US$) of Ethiopia in 2002?
Offer a very short reply. 4.57e+07. What is the difference between the Aid flow (current US$) in High income: nonOECD in 2001 and the Aid flow (current US$) in Latvia in 2002?
Provide a short and direct response. 8.26e+07. What is the difference between the Aid flow (current US$) of Armenia in 2001 and the Aid flow (current US$) of Ethiopia in 2002?
Provide a short and direct response. -2.38e+07. What is the difference between the Aid flow (current US$) of Armenia in 2001 and the Aid flow (current US$) of Latvia in 2002?
Offer a very short reply. 1.30e+07. What is the difference between the Aid flow (current US$) of Ethiopia in 2001 and the Aid flow (current US$) of Latvia in 2002?
Offer a terse response. 2.21e+07. What is the difference between the Aid flow (current US$) of High income: nonOECD in 2001 and the Aid flow (current US$) of Armenia in 2003?
Provide a short and direct response. 7.24e+07. What is the difference between the Aid flow (current US$) in High income: nonOECD in 2001 and the Aid flow (current US$) in Ethiopia in 2003?
Your answer should be compact. 3.87e+07. What is the difference between the Aid flow (current US$) of High income: nonOECD in 2001 and the Aid flow (current US$) of Latvia in 2003?
Your response must be concise. 8.05e+07. What is the difference between the Aid flow (current US$) in Armenia in 2001 and the Aid flow (current US$) in Ethiopia in 2003?
Your response must be concise. -3.08e+07. What is the difference between the Aid flow (current US$) in Armenia in 2001 and the Aid flow (current US$) in Latvia in 2003?
Ensure brevity in your answer.  1.10e+07. What is the difference between the Aid flow (current US$) of Ethiopia in 2001 and the Aid flow (current US$) of Latvia in 2003?
Give a very brief answer. 2.00e+07. What is the difference between the Aid flow (current US$) in High income: nonOECD in 2002 and the Aid flow (current US$) in Armenia in 2003?
Ensure brevity in your answer.  6.58e+07. What is the difference between the Aid flow (current US$) of High income: nonOECD in 2002 and the Aid flow (current US$) of Ethiopia in 2003?
Your answer should be compact. 3.21e+07. What is the difference between the Aid flow (current US$) of High income: nonOECD in 2002 and the Aid flow (current US$) of Latvia in 2003?
Your answer should be very brief. 7.38e+07. What is the difference between the Aid flow (current US$) of Armenia in 2002 and the Aid flow (current US$) of Ethiopia in 2003?
Provide a succinct answer. -2.77e+07. What is the difference between the Aid flow (current US$) in Armenia in 2002 and the Aid flow (current US$) in Latvia in 2003?
Give a very brief answer. 1.41e+07. What is the difference between the Aid flow (current US$) of Ethiopia in 2002 and the Aid flow (current US$) of Latvia in 2003?
Make the answer very short. 3.48e+07. What is the average Aid flow (current US$) of High income: nonOECD per year?
Your response must be concise. 1.61e+08. What is the average Aid flow (current US$) in Armenia per year?
Provide a short and direct response. 1.03e+07. What is the average Aid flow (current US$) in Ethiopia per year?
Keep it short and to the point. 4.92e+07. What is the average Aid flow (current US$) of Latvia per year?
Ensure brevity in your answer.  6.57e+06. In the year 1996, what is the difference between the Aid flow (current US$) of High income: nonOECD and Aid flow (current US$) of Armenia?
Your response must be concise. 5.98e+08. In the year 1996, what is the difference between the Aid flow (current US$) in High income: nonOECD and Aid flow (current US$) in Ethiopia?
Your answer should be compact. 5.23e+08. In the year 1996, what is the difference between the Aid flow (current US$) of High income: nonOECD and Aid flow (current US$) of Latvia?
Ensure brevity in your answer.  5.92e+08. In the year 1996, what is the difference between the Aid flow (current US$) in Armenia and Aid flow (current US$) in Ethiopia?
Your answer should be compact. -7.47e+07. In the year 1996, what is the difference between the Aid flow (current US$) of Armenia and Aid flow (current US$) of Latvia?
Offer a very short reply. -5.34e+06. In the year 1996, what is the difference between the Aid flow (current US$) of Ethiopia and Aid flow (current US$) of Latvia?
Give a very brief answer. 6.94e+07. In the year 1997, what is the difference between the Aid flow (current US$) of High income: nonOECD and Aid flow (current US$) of Armenia?
Your response must be concise. 9.83e+07. In the year 1997, what is the difference between the Aid flow (current US$) in High income: nonOECD and Aid flow (current US$) in Ethiopia?
Give a very brief answer. 4.41e+07. In the year 1997, what is the difference between the Aid flow (current US$) of High income: nonOECD and Aid flow (current US$) of Latvia?
Your response must be concise. 9.48e+07. In the year 1997, what is the difference between the Aid flow (current US$) of Armenia and Aid flow (current US$) of Ethiopia?
Keep it short and to the point. -5.42e+07. In the year 1997, what is the difference between the Aid flow (current US$) of Armenia and Aid flow (current US$) of Latvia?
Make the answer very short. -3.46e+06. In the year 1997, what is the difference between the Aid flow (current US$) in Ethiopia and Aid flow (current US$) in Latvia?
Make the answer very short. 5.07e+07. In the year 1998, what is the difference between the Aid flow (current US$) of High income: nonOECD and Aid flow (current US$) of Armenia?
Keep it short and to the point. 1.05e+08. In the year 1998, what is the difference between the Aid flow (current US$) of High income: nonOECD and Aid flow (current US$) of Ethiopia?
Ensure brevity in your answer.  4.68e+07. In the year 1998, what is the difference between the Aid flow (current US$) in High income: nonOECD and Aid flow (current US$) in Latvia?
Make the answer very short. 1.03e+08. In the year 1998, what is the difference between the Aid flow (current US$) of Armenia and Aid flow (current US$) of Ethiopia?
Offer a very short reply. -5.84e+07. In the year 1998, what is the difference between the Aid flow (current US$) in Armenia and Aid flow (current US$) in Latvia?
Your answer should be compact. -2.45e+06. In the year 1998, what is the difference between the Aid flow (current US$) in Ethiopia and Aid flow (current US$) in Latvia?
Ensure brevity in your answer.  5.60e+07. In the year 1999, what is the difference between the Aid flow (current US$) in High income: nonOECD and Aid flow (current US$) in Armenia?
Provide a short and direct response. 1.02e+08. In the year 1999, what is the difference between the Aid flow (current US$) of High income: nonOECD and Aid flow (current US$) of Ethiopia?
Provide a succinct answer. 7.14e+07. In the year 1999, what is the difference between the Aid flow (current US$) in High income: nonOECD and Aid flow (current US$) in Latvia?
Keep it short and to the point. 1.03e+08. In the year 1999, what is the difference between the Aid flow (current US$) of Armenia and Aid flow (current US$) of Ethiopia?
Provide a succinct answer. -3.06e+07. In the year 1999, what is the difference between the Aid flow (current US$) in Armenia and Aid flow (current US$) in Latvia?
Make the answer very short. 1.39e+06. In the year 1999, what is the difference between the Aid flow (current US$) in Ethiopia and Aid flow (current US$) in Latvia?
Provide a short and direct response. 3.20e+07. In the year 2000, what is the difference between the Aid flow (current US$) of High income: nonOECD and Aid flow (current US$) of Armenia?
Make the answer very short. 7.77e+07. In the year 2000, what is the difference between the Aid flow (current US$) of High income: nonOECD and Aid flow (current US$) of Ethiopia?
Your answer should be compact. 4.80e+07. In the year 2000, what is the difference between the Aid flow (current US$) of High income: nonOECD and Aid flow (current US$) of Latvia?
Make the answer very short. 8.09e+07. In the year 2000, what is the difference between the Aid flow (current US$) in Armenia and Aid flow (current US$) in Ethiopia?
Offer a terse response. -2.97e+07. In the year 2000, what is the difference between the Aid flow (current US$) in Armenia and Aid flow (current US$) in Latvia?
Make the answer very short. 3.19e+06. In the year 2000, what is the difference between the Aid flow (current US$) in Ethiopia and Aid flow (current US$) in Latvia?
Your response must be concise. 3.29e+07. In the year 2001, what is the difference between the Aid flow (current US$) of High income: nonOECD and Aid flow (current US$) of Armenia?
Your response must be concise. 6.95e+07. In the year 2001, what is the difference between the Aid flow (current US$) of High income: nonOECD and Aid flow (current US$) of Ethiopia?
Your answer should be compact. 6.04e+07. In the year 2001, what is the difference between the Aid flow (current US$) of High income: nonOECD and Aid flow (current US$) of Latvia?
Provide a short and direct response. 8.17e+07. In the year 2001, what is the difference between the Aid flow (current US$) in Armenia and Aid flow (current US$) in Ethiopia?
Ensure brevity in your answer.  -9.08e+06. In the year 2001, what is the difference between the Aid flow (current US$) of Armenia and Aid flow (current US$) of Latvia?
Keep it short and to the point. 1.22e+07. In the year 2001, what is the difference between the Aid flow (current US$) of Ethiopia and Aid flow (current US$) of Latvia?
Your response must be concise. 2.12e+07. In the year 2002, what is the difference between the Aid flow (current US$) of High income: nonOECD and Aid flow (current US$) of Armenia?
Provide a short and direct response. 5.98e+07. In the year 2002, what is the difference between the Aid flow (current US$) of High income: nonOECD and Aid flow (current US$) of Ethiopia?
Provide a short and direct response. 3.91e+07. In the year 2002, what is the difference between the Aid flow (current US$) of High income: nonOECD and Aid flow (current US$) of Latvia?
Your answer should be very brief. 7.59e+07. In the year 2002, what is the difference between the Aid flow (current US$) of Armenia and Aid flow (current US$) of Ethiopia?
Your answer should be compact. -2.07e+07. In the year 2002, what is the difference between the Aid flow (current US$) of Armenia and Aid flow (current US$) of Latvia?
Provide a succinct answer. 1.62e+07. In the year 2002, what is the difference between the Aid flow (current US$) in Ethiopia and Aid flow (current US$) in Latvia?
Keep it short and to the point. 3.68e+07. In the year 2003, what is the difference between the Aid flow (current US$) of High income: nonOECD and Aid flow (current US$) of Armenia?
Your answer should be compact. 9.68e+07. In the year 2003, what is the difference between the Aid flow (current US$) in High income: nonOECD and Aid flow (current US$) in Ethiopia?
Your answer should be very brief. 6.31e+07. In the year 2003, what is the difference between the Aid flow (current US$) in High income: nonOECD and Aid flow (current US$) in Latvia?
Provide a succinct answer. 1.05e+08. In the year 2003, what is the difference between the Aid flow (current US$) of Armenia and Aid flow (current US$) of Ethiopia?
Your answer should be compact. -3.37e+07. In the year 2003, what is the difference between the Aid flow (current US$) of Armenia and Aid flow (current US$) of Latvia?
Give a very brief answer. 8.08e+06. In the year 2003, what is the difference between the Aid flow (current US$) in Ethiopia and Aid flow (current US$) in Latvia?
Your response must be concise. 4.18e+07. What is the ratio of the Aid flow (current US$) in High income: nonOECD in 1996 to that in 1997?
Ensure brevity in your answer.  5.9. What is the ratio of the Aid flow (current US$) of Armenia in 1996 to that in 1997?
Provide a succinct answer. 1.63. What is the ratio of the Aid flow (current US$) of Ethiopia in 1996 to that in 1997?
Provide a short and direct response. 1.4. What is the ratio of the Aid flow (current US$) in Latvia in 1996 to that in 1997?
Provide a short and direct response. 1.59. What is the ratio of the Aid flow (current US$) of High income: nonOECD in 1996 to that in 1998?
Your answer should be compact. 5.48. What is the ratio of the Aid flow (current US$) of Armenia in 1996 to that in 1998?
Your answer should be compact. 1.32. What is the ratio of the Aid flow (current US$) in Ethiopia in 1996 to that in 1998?
Keep it short and to the point. 1.28. What is the ratio of the Aid flow (current US$) of Latvia in 1996 to that in 1998?
Your answer should be compact. 1.6. What is the ratio of the Aid flow (current US$) of High income: nonOECD in 1996 to that in 1999?
Give a very brief answer. 5.55. What is the ratio of the Aid flow (current US$) of Armenia in 1996 to that in 1999?
Keep it short and to the point. 0.98. What is the ratio of the Aid flow (current US$) in Ethiopia in 1996 to that in 1999?
Your response must be concise. 2.17. What is the ratio of the Aid flow (current US$) in Latvia in 1996 to that in 1999?
Offer a terse response. 2.2. What is the ratio of the Aid flow (current US$) in High income: nonOECD in 1996 to that in 2000?
Your answer should be very brief. 6.98. What is the ratio of the Aid flow (current US$) in Armenia in 1996 to that in 2000?
Ensure brevity in your answer.  0.75. What is the ratio of the Aid flow (current US$) of Ethiopia in 1996 to that in 2000?
Provide a short and direct response. 2.11. What is the ratio of the Aid flow (current US$) of Latvia in 1996 to that in 2000?
Keep it short and to the point. 2.1. What is the ratio of the Aid flow (current US$) in High income: nonOECD in 1996 to that in 2001?
Offer a terse response. 7. What is the ratio of the Aid flow (current US$) in Armenia in 1996 to that in 2001?
Give a very brief answer. 0.4. What is the ratio of the Aid flow (current US$) in Ethiopia in 1996 to that in 2001?
Your answer should be very brief. 3.15. What is the ratio of the Aid flow (current US$) of Latvia in 1996 to that in 2001?
Provide a succinct answer. 2.59. What is the ratio of the Aid flow (current US$) of High income: nonOECD in 1996 to that in 2002?
Provide a short and direct response. 7.58. What is the ratio of the Aid flow (current US$) of Armenia in 1996 to that in 2002?
Your response must be concise. 0.34. What is the ratio of the Aid flow (current US$) in Ethiopia in 1996 to that in 2002?
Offer a very short reply. 2.01. What is the ratio of the Aid flow (current US$) of Latvia in 1996 to that in 2002?
Keep it short and to the point. 3.2. What is the ratio of the Aid flow (current US$) of High income: nonOECD in 1996 to that in 2003?
Your answer should be compact. 5.46. What is the ratio of the Aid flow (current US$) of Armenia in 1996 to that in 2003?
Your answer should be very brief. 0.48. What is the ratio of the Aid flow (current US$) of Ethiopia in 1996 to that in 2003?
Offer a very short reply. 1.71. What is the ratio of the Aid flow (current US$) in Latvia in 1996 to that in 2003?
Your response must be concise. 2.06. What is the ratio of the Aid flow (current US$) in High income: nonOECD in 1997 to that in 1998?
Provide a succinct answer. 0.93. What is the ratio of the Aid flow (current US$) in Armenia in 1997 to that in 1998?
Your answer should be very brief. 0.81. What is the ratio of the Aid flow (current US$) of Ethiopia in 1997 to that in 1998?
Ensure brevity in your answer.  0.92. What is the ratio of the Aid flow (current US$) of Latvia in 1997 to that in 1998?
Provide a succinct answer. 1.01. What is the ratio of the Aid flow (current US$) in High income: nonOECD in 1997 to that in 1999?
Ensure brevity in your answer.  0.94. What is the ratio of the Aid flow (current US$) of Armenia in 1997 to that in 1999?
Provide a succinct answer. 0.6. What is the ratio of the Aid flow (current US$) of Ethiopia in 1997 to that in 1999?
Offer a terse response. 1.56. What is the ratio of the Aid flow (current US$) of Latvia in 1997 to that in 1999?
Your answer should be very brief. 1.38. What is the ratio of the Aid flow (current US$) in High income: nonOECD in 1997 to that in 2000?
Your answer should be very brief. 1.18. What is the ratio of the Aid flow (current US$) of Armenia in 1997 to that in 2000?
Your answer should be very brief. 0.46. What is the ratio of the Aid flow (current US$) of Ethiopia in 1997 to that in 2000?
Provide a succinct answer. 1.51. What is the ratio of the Aid flow (current US$) in Latvia in 1997 to that in 2000?
Offer a terse response. 1.32. What is the ratio of the Aid flow (current US$) in High income: nonOECD in 1997 to that in 2001?
Your answer should be compact. 1.19. What is the ratio of the Aid flow (current US$) in Armenia in 1997 to that in 2001?
Offer a very short reply. 0.24. What is the ratio of the Aid flow (current US$) in Ethiopia in 1997 to that in 2001?
Offer a very short reply. 2.25. What is the ratio of the Aid flow (current US$) of Latvia in 1997 to that in 2001?
Make the answer very short. 1.63. What is the ratio of the Aid flow (current US$) of High income: nonOECD in 1997 to that in 2002?
Your answer should be compact. 1.28. What is the ratio of the Aid flow (current US$) in Armenia in 1997 to that in 2002?
Offer a terse response. 0.21. What is the ratio of the Aid flow (current US$) in Ethiopia in 1997 to that in 2002?
Offer a terse response. 1.44. What is the ratio of the Aid flow (current US$) in Latvia in 1997 to that in 2002?
Ensure brevity in your answer.  2.01. What is the ratio of the Aid flow (current US$) of High income: nonOECD in 1997 to that in 2003?
Your answer should be very brief. 0.92. What is the ratio of the Aid flow (current US$) in Armenia in 1997 to that in 2003?
Your answer should be compact. 0.3. What is the ratio of the Aid flow (current US$) in Ethiopia in 1997 to that in 2003?
Ensure brevity in your answer.  1.22. What is the ratio of the Aid flow (current US$) in Latvia in 1997 to that in 2003?
Provide a short and direct response. 1.3. What is the ratio of the Aid flow (current US$) in High income: nonOECD in 1998 to that in 1999?
Make the answer very short. 1.01. What is the ratio of the Aid flow (current US$) in Armenia in 1998 to that in 1999?
Your answer should be very brief. 0.74. What is the ratio of the Aid flow (current US$) in Ethiopia in 1998 to that in 1999?
Your answer should be compact. 1.69. What is the ratio of the Aid flow (current US$) of Latvia in 1998 to that in 1999?
Your response must be concise. 1.38. What is the ratio of the Aid flow (current US$) of High income: nonOECD in 1998 to that in 2000?
Offer a very short reply. 1.27. What is the ratio of the Aid flow (current US$) of Armenia in 1998 to that in 2000?
Your answer should be very brief. 0.57. What is the ratio of the Aid flow (current US$) in Ethiopia in 1998 to that in 2000?
Your answer should be very brief. 1.64. What is the ratio of the Aid flow (current US$) in Latvia in 1998 to that in 2000?
Ensure brevity in your answer.  1.31. What is the ratio of the Aid flow (current US$) of High income: nonOECD in 1998 to that in 2001?
Provide a short and direct response. 1.28. What is the ratio of the Aid flow (current US$) of Armenia in 1998 to that in 2001?
Provide a short and direct response. 0.3. What is the ratio of the Aid flow (current US$) of Ethiopia in 1998 to that in 2001?
Offer a terse response. 2.45. What is the ratio of the Aid flow (current US$) in Latvia in 1998 to that in 2001?
Keep it short and to the point. 1.62. What is the ratio of the Aid flow (current US$) of High income: nonOECD in 1998 to that in 2002?
Provide a succinct answer. 1.38. What is the ratio of the Aid flow (current US$) of Armenia in 1998 to that in 2002?
Your answer should be compact. 0.25. What is the ratio of the Aid flow (current US$) in Ethiopia in 1998 to that in 2002?
Keep it short and to the point. 1.56. What is the ratio of the Aid flow (current US$) of Latvia in 1998 to that in 2002?
Your answer should be very brief. 2. What is the ratio of the Aid flow (current US$) in Armenia in 1998 to that in 2003?
Your answer should be very brief. 0.36. What is the ratio of the Aid flow (current US$) of Ethiopia in 1998 to that in 2003?
Provide a succinct answer. 1.33. What is the ratio of the Aid flow (current US$) of Latvia in 1998 to that in 2003?
Keep it short and to the point. 1.29. What is the ratio of the Aid flow (current US$) in High income: nonOECD in 1999 to that in 2000?
Offer a terse response. 1.26. What is the ratio of the Aid flow (current US$) in Armenia in 1999 to that in 2000?
Provide a short and direct response. 0.77. What is the ratio of the Aid flow (current US$) in Ethiopia in 1999 to that in 2000?
Provide a succinct answer. 0.97. What is the ratio of the Aid flow (current US$) in Latvia in 1999 to that in 2000?
Your answer should be compact. 0.95. What is the ratio of the Aid flow (current US$) of High income: nonOECD in 1999 to that in 2001?
Your response must be concise. 1.26. What is the ratio of the Aid flow (current US$) of Armenia in 1999 to that in 2001?
Offer a terse response. 0.41. What is the ratio of the Aid flow (current US$) in Ethiopia in 1999 to that in 2001?
Offer a terse response. 1.45. What is the ratio of the Aid flow (current US$) of Latvia in 1999 to that in 2001?
Keep it short and to the point. 1.18. What is the ratio of the Aid flow (current US$) of High income: nonOECD in 1999 to that in 2002?
Keep it short and to the point. 1.37. What is the ratio of the Aid flow (current US$) in Armenia in 1999 to that in 2002?
Provide a short and direct response. 0.34. What is the ratio of the Aid flow (current US$) in Ethiopia in 1999 to that in 2002?
Your response must be concise. 0.92. What is the ratio of the Aid flow (current US$) of Latvia in 1999 to that in 2002?
Your answer should be very brief. 1.45. What is the ratio of the Aid flow (current US$) of High income: nonOECD in 1999 to that in 2003?
Your answer should be very brief. 0.98. What is the ratio of the Aid flow (current US$) of Armenia in 1999 to that in 2003?
Keep it short and to the point. 0.49. What is the ratio of the Aid flow (current US$) of Ethiopia in 1999 to that in 2003?
Provide a short and direct response. 0.79. What is the ratio of the Aid flow (current US$) in Latvia in 1999 to that in 2003?
Ensure brevity in your answer.  0.94. What is the ratio of the Aid flow (current US$) in Armenia in 2000 to that in 2001?
Ensure brevity in your answer.  0.53. What is the ratio of the Aid flow (current US$) of Ethiopia in 2000 to that in 2001?
Your answer should be very brief. 1.49. What is the ratio of the Aid flow (current US$) in Latvia in 2000 to that in 2001?
Your response must be concise. 1.23. What is the ratio of the Aid flow (current US$) in High income: nonOECD in 2000 to that in 2002?
Your answer should be compact. 1.09. What is the ratio of the Aid flow (current US$) in Armenia in 2000 to that in 2002?
Ensure brevity in your answer.  0.45. What is the ratio of the Aid flow (current US$) in Ethiopia in 2000 to that in 2002?
Offer a very short reply. 0.95. What is the ratio of the Aid flow (current US$) of Latvia in 2000 to that in 2002?
Offer a very short reply. 1.52. What is the ratio of the Aid flow (current US$) of High income: nonOECD in 2000 to that in 2003?
Offer a terse response. 0.78. What is the ratio of the Aid flow (current US$) in Armenia in 2000 to that in 2003?
Provide a short and direct response. 0.64. What is the ratio of the Aid flow (current US$) of Ethiopia in 2000 to that in 2003?
Your response must be concise. 0.81. What is the ratio of the Aid flow (current US$) of Latvia in 2000 to that in 2003?
Ensure brevity in your answer.  0.98. What is the ratio of the Aid flow (current US$) in High income: nonOECD in 2001 to that in 2002?
Give a very brief answer. 1.08. What is the ratio of the Aid flow (current US$) of Armenia in 2001 to that in 2002?
Your answer should be very brief. 0.84. What is the ratio of the Aid flow (current US$) of Ethiopia in 2001 to that in 2002?
Make the answer very short. 0.64. What is the ratio of the Aid flow (current US$) in Latvia in 2001 to that in 2002?
Offer a very short reply. 1.23. What is the ratio of the Aid flow (current US$) in High income: nonOECD in 2001 to that in 2003?
Keep it short and to the point. 0.78. What is the ratio of the Aid flow (current US$) of Armenia in 2001 to that in 2003?
Make the answer very short. 1.21. What is the ratio of the Aid flow (current US$) of Ethiopia in 2001 to that in 2003?
Ensure brevity in your answer.  0.54. What is the ratio of the Aid flow (current US$) of Latvia in 2001 to that in 2003?
Give a very brief answer. 0.79. What is the ratio of the Aid flow (current US$) of High income: nonOECD in 2002 to that in 2003?
Provide a succinct answer. 0.72. What is the ratio of the Aid flow (current US$) in Armenia in 2002 to that in 2003?
Offer a very short reply. 1.43. What is the ratio of the Aid flow (current US$) in Ethiopia in 2002 to that in 2003?
Offer a very short reply. 0.85. What is the ratio of the Aid flow (current US$) of Latvia in 2002 to that in 2003?
Ensure brevity in your answer.  0.64. What is the difference between the highest and the second highest Aid flow (current US$) of High income: nonOECD?
Offer a terse response. 4.94e+08. What is the difference between the highest and the second highest Aid flow (current US$) in Armenia?
Give a very brief answer. 3.14e+06. What is the difference between the highest and the second highest Aid flow (current US$) in Ethiopia?
Ensure brevity in your answer.  1.79e+07. What is the difference between the highest and the second highest Aid flow (current US$) of Latvia?
Offer a terse response. 4.47e+06. What is the difference between the highest and the lowest Aid flow (current US$) in High income: nonOECD?
Provide a short and direct response. 5.25e+08. What is the difference between the highest and the lowest Aid flow (current US$) in Armenia?
Your answer should be compact. 1.58e+07. What is the difference between the highest and the lowest Aid flow (current US$) in Ethiopia?
Your response must be concise. 5.56e+07. What is the difference between the highest and the lowest Aid flow (current US$) in Latvia?
Provide a succinct answer. 8.28e+06. 